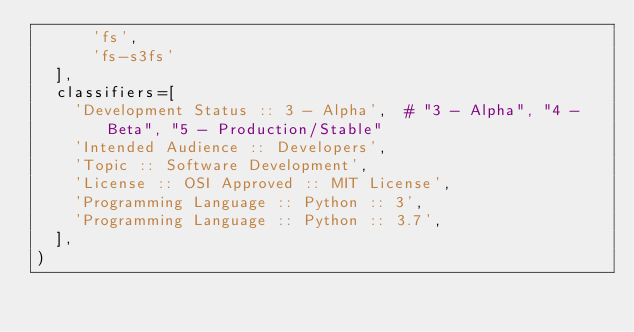Convert code to text. <code><loc_0><loc_0><loc_500><loc_500><_Python_>      'fs',
      'fs-s3fs'
  ],
  classifiers=[
    'Development Status :: 3 - Alpha',  # "3 - Alpha", "4 - Beta", "5 - Production/Stable"
    'Intended Audience :: Developers',
    'Topic :: Software Development',
    'License :: OSI Approved :: MIT License',
    'Programming Language :: Python :: 3',
    'Programming Language :: Python :: 3.7',
  ],
)</code> 